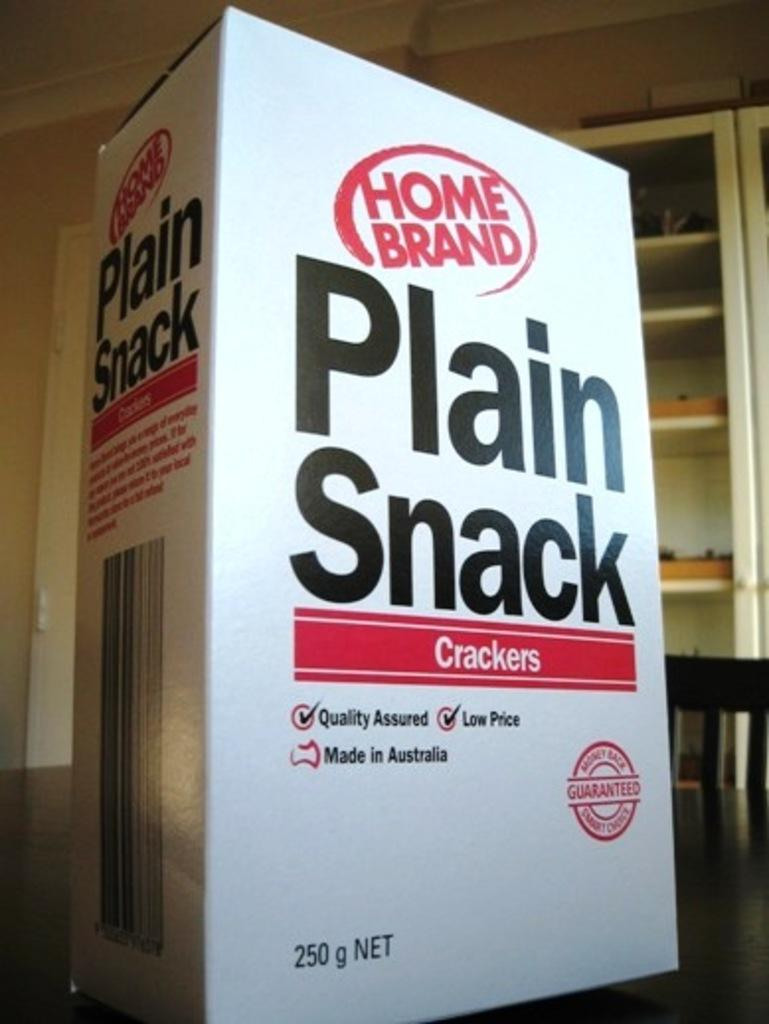<image>
Write a terse but informative summary of the picture. White box of Home Brand plain snack crackers. 